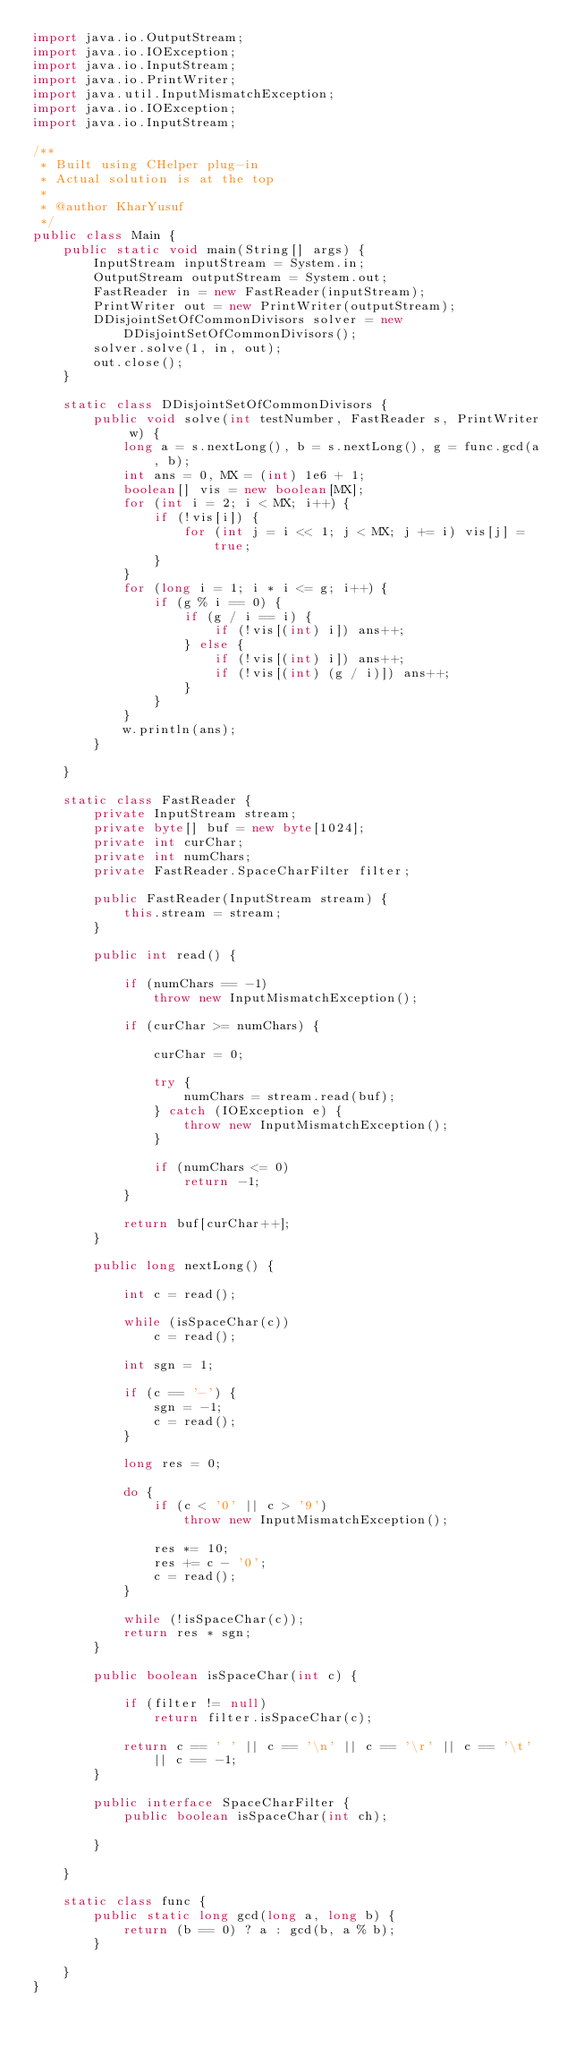Convert code to text. <code><loc_0><loc_0><loc_500><loc_500><_Java_>import java.io.OutputStream;
import java.io.IOException;
import java.io.InputStream;
import java.io.PrintWriter;
import java.util.InputMismatchException;
import java.io.IOException;
import java.io.InputStream;

/**
 * Built using CHelper plug-in
 * Actual solution is at the top
 *
 * @author KharYusuf
 */
public class Main {
    public static void main(String[] args) {
        InputStream inputStream = System.in;
        OutputStream outputStream = System.out;
        FastReader in = new FastReader(inputStream);
        PrintWriter out = new PrintWriter(outputStream);
        DDisjointSetOfCommonDivisors solver = new DDisjointSetOfCommonDivisors();
        solver.solve(1, in, out);
        out.close();
    }

    static class DDisjointSetOfCommonDivisors {
        public void solve(int testNumber, FastReader s, PrintWriter w) {
            long a = s.nextLong(), b = s.nextLong(), g = func.gcd(a, b);
            int ans = 0, MX = (int) 1e6 + 1;
            boolean[] vis = new boolean[MX];
            for (int i = 2; i < MX; i++) {
                if (!vis[i]) {
                    for (int j = i << 1; j < MX; j += i) vis[j] = true;
                }
            }
            for (long i = 1; i * i <= g; i++) {
                if (g % i == 0) {
                    if (g / i == i) {
                        if (!vis[(int) i]) ans++;
                    } else {
                        if (!vis[(int) i]) ans++;
                        if (!vis[(int) (g / i)]) ans++;
                    }
                }
            }
            w.println(ans);
        }

    }

    static class FastReader {
        private InputStream stream;
        private byte[] buf = new byte[1024];
        private int curChar;
        private int numChars;
        private FastReader.SpaceCharFilter filter;

        public FastReader(InputStream stream) {
            this.stream = stream;
        }

        public int read() {

            if (numChars == -1)
                throw new InputMismatchException();

            if (curChar >= numChars) {

                curChar = 0;

                try {
                    numChars = stream.read(buf);
                } catch (IOException e) {
                    throw new InputMismatchException();
                }

                if (numChars <= 0)
                    return -1;
            }

            return buf[curChar++];
        }

        public long nextLong() {

            int c = read();

            while (isSpaceChar(c))
                c = read();

            int sgn = 1;

            if (c == '-') {
                sgn = -1;
                c = read();
            }

            long res = 0;

            do {
                if (c < '0' || c > '9')
                    throw new InputMismatchException();

                res *= 10;
                res += c - '0';
                c = read();
            }

            while (!isSpaceChar(c));
            return res * sgn;
        }

        public boolean isSpaceChar(int c) {

            if (filter != null)
                return filter.isSpaceChar(c);

            return c == ' ' || c == '\n' || c == '\r' || c == '\t' || c == -1;
        }

        public interface SpaceCharFilter {
            public boolean isSpaceChar(int ch);

        }

    }

    static class func {
        public static long gcd(long a, long b) {
            return (b == 0) ? a : gcd(b, a % b);
        }

    }
}

</code> 